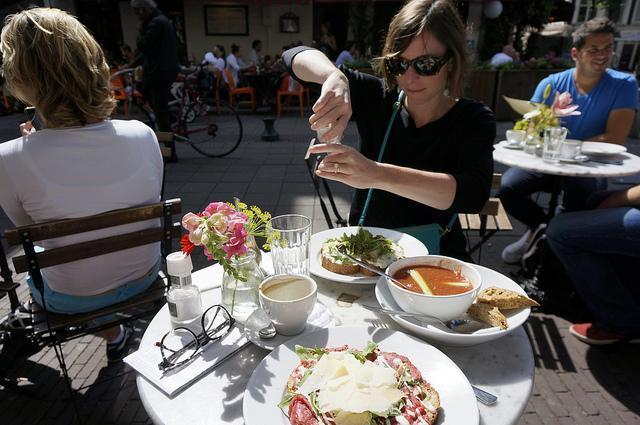How many cups can be seen?
Give a very brief answer. 2. How many dining tables are there?
Give a very brief answer. 2. How many people can be seen?
Give a very brief answer. 5. How many chairs can be seen?
Give a very brief answer. 1. How many zebras are pictured?
Give a very brief answer. 0. 